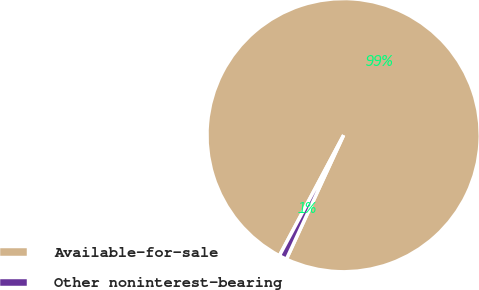Convert chart to OTSL. <chart><loc_0><loc_0><loc_500><loc_500><pie_chart><fcel>Available-for-sale<fcel>Other noninterest-bearing<nl><fcel>99.09%<fcel>0.91%<nl></chart> 